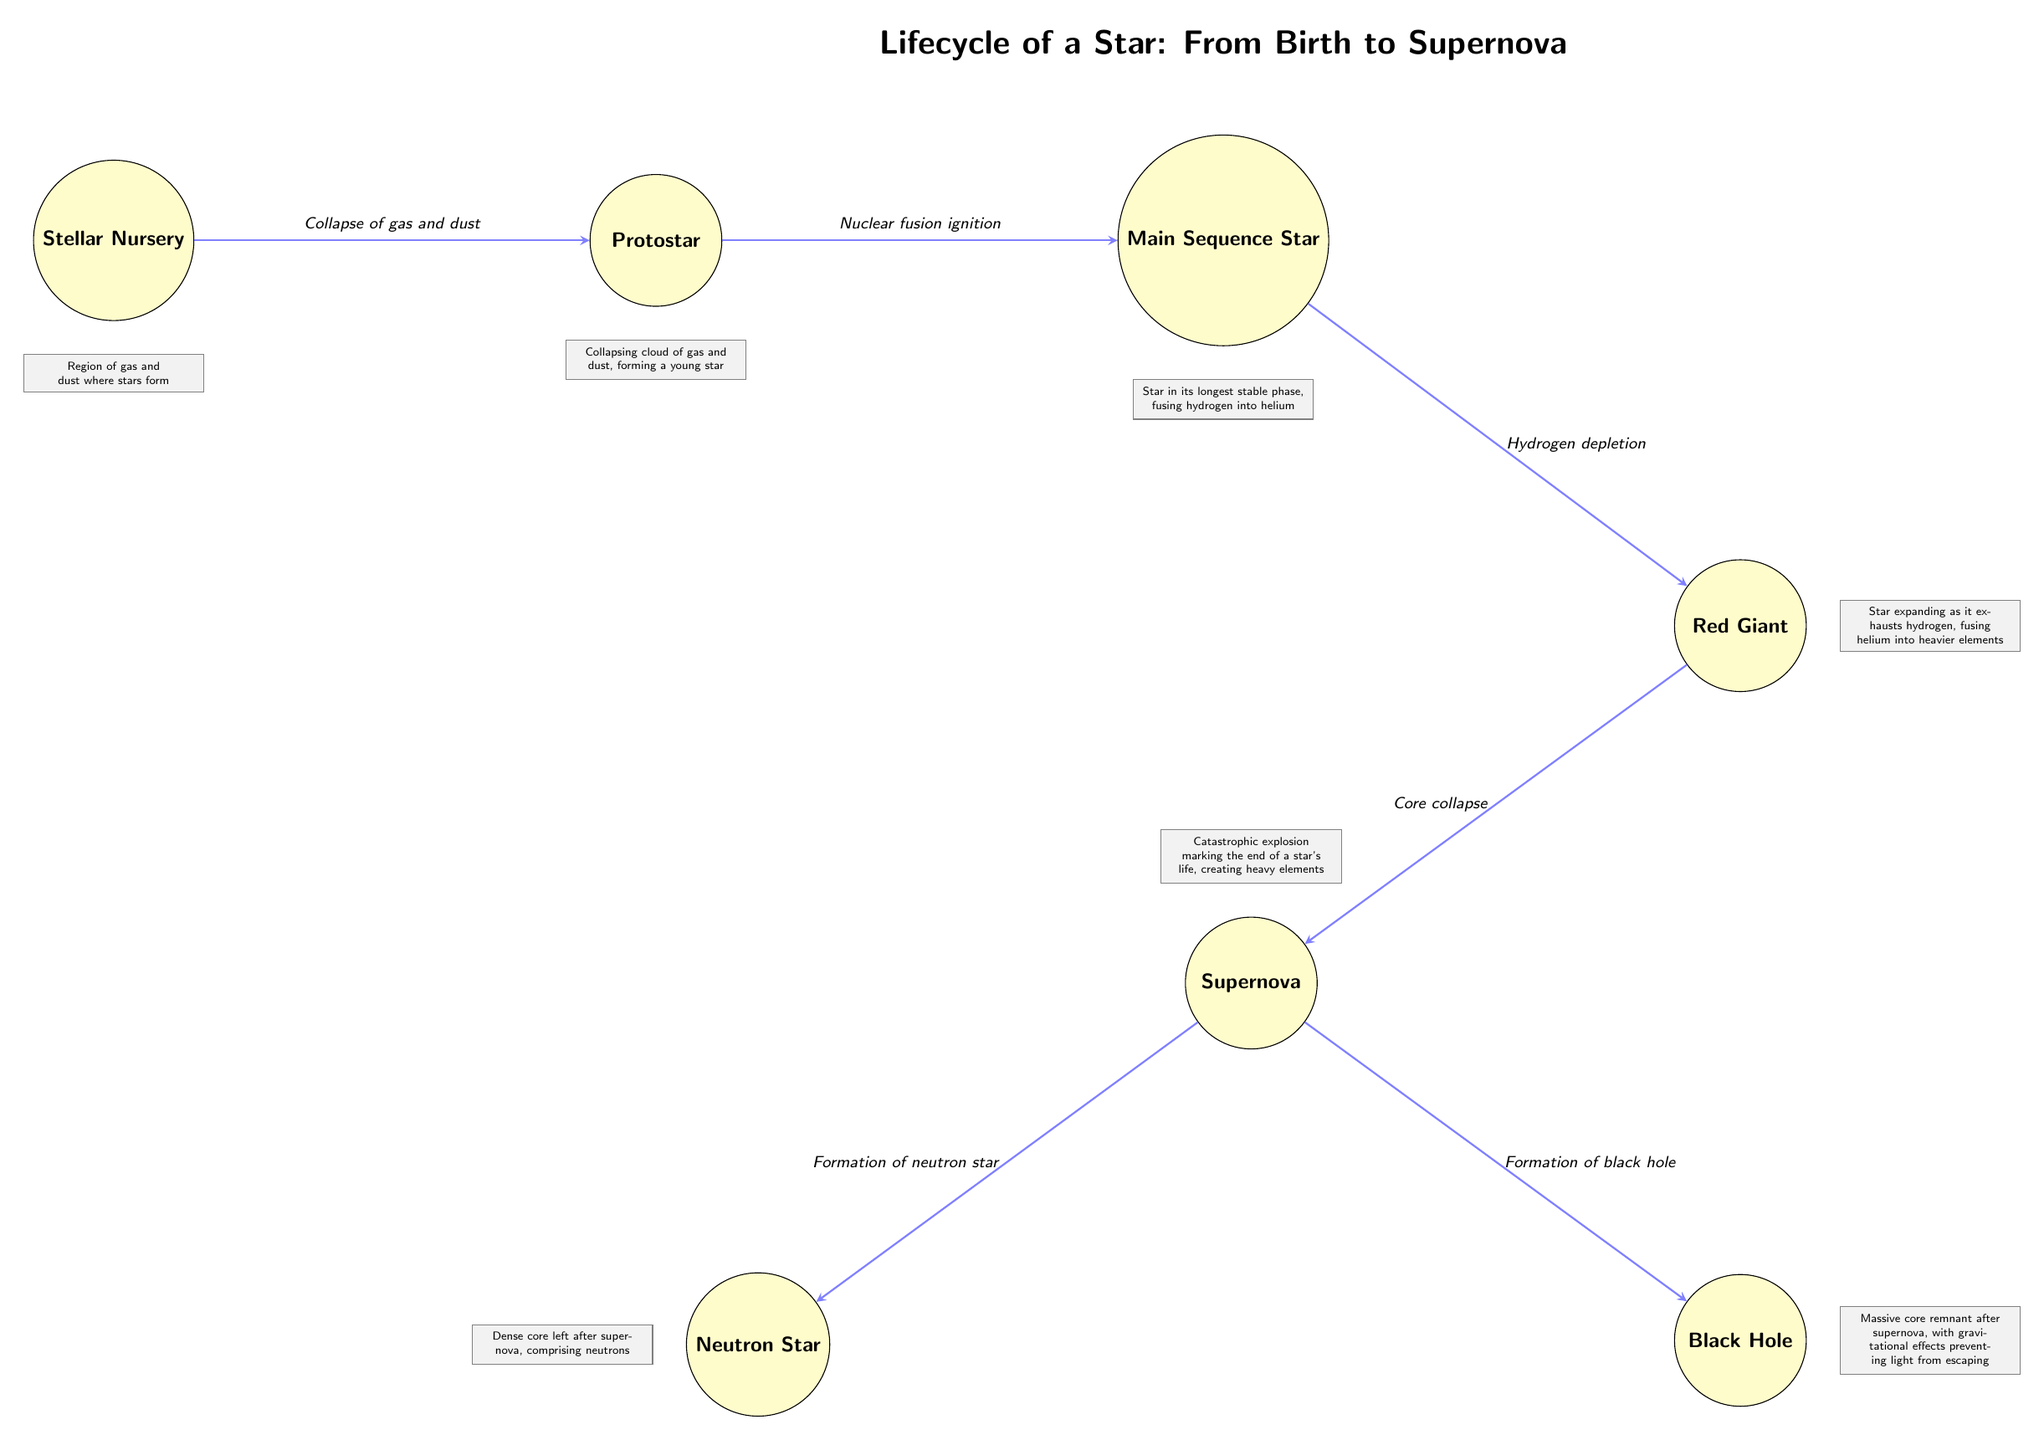What is the first stage of a star's lifecycle? The diagram indicates that the first stage of a star's lifecycle is the "Stellar Nursery." This is the initial point from which all stars develop as they are formed from gas and dust.
Answer: Stellar Nursery Which process leads to the creation of a Protostar? According to the diagram, the process that leads to the creation of a Protostar is the "Collapse of gas and dust." This indicates the transition from the nebulous stellar nursery to a more defined structure.
Answer: Collapse of gas and dust What occurs when a Main Sequence Star depletes hydrogen? The diagram shows that once a Main Sequence Star depletes its hydrogen, it enters the "Red Giant" phase. This is a crucial transition characterized by expansion and changes in the fusion processes within the star.
Answer: Red Giant What are the two possible outcomes after a Supernova? The diagram specifies that after a Supernova, the two possible outcomes are the formation of a "Neutron Star" and a "Black Hole." These outcomes depend on the mass of the remaining core after the explosive end of the star's lifecycle.
Answer: Neutron Star, Black Hole How many main stages are shown in the diagram? The diagram illustrates a total of six main stages in the lifecycle of a star. This accounts for each distinct phase from the Stellar Nursery to the Supernova and its subsequent outcomes.
Answer: Six What happens during the process of core collapse? In the diagram, the core collapse occurs during the transition from the "Red Giant" to the "Supernova." This process signifies the star's last moments leading to a massive explosion, marking the end of its life.
Answer: Supernova What does the note under the Main Sequence Star describe? The note under the Main Sequence Star describes it as a star in its "longest stable phase, fusing hydrogen into helium." This highlights the main energy-producing reaction that sustains the star's stability.
Answer: Longest stable phase, fusing hydrogen into helium What type of explosion marks the end of a star's lifecycle? The diagram depicts that a "Supernova" is the type of explosion that marks the end of a star's lifecycle. This catastrophic event causes the elements formed in the star to be dispersed into the universe.
Answer: Supernova What element is primarily fused in the Main Sequence Star? The diagram indicates that in a Main Sequence Star, "Hydrogen" is primarily fused into helium during this stable phase of its life. This fusion is vital for sustaining the star against gravitational collapse.
Answer: Hydrogen 